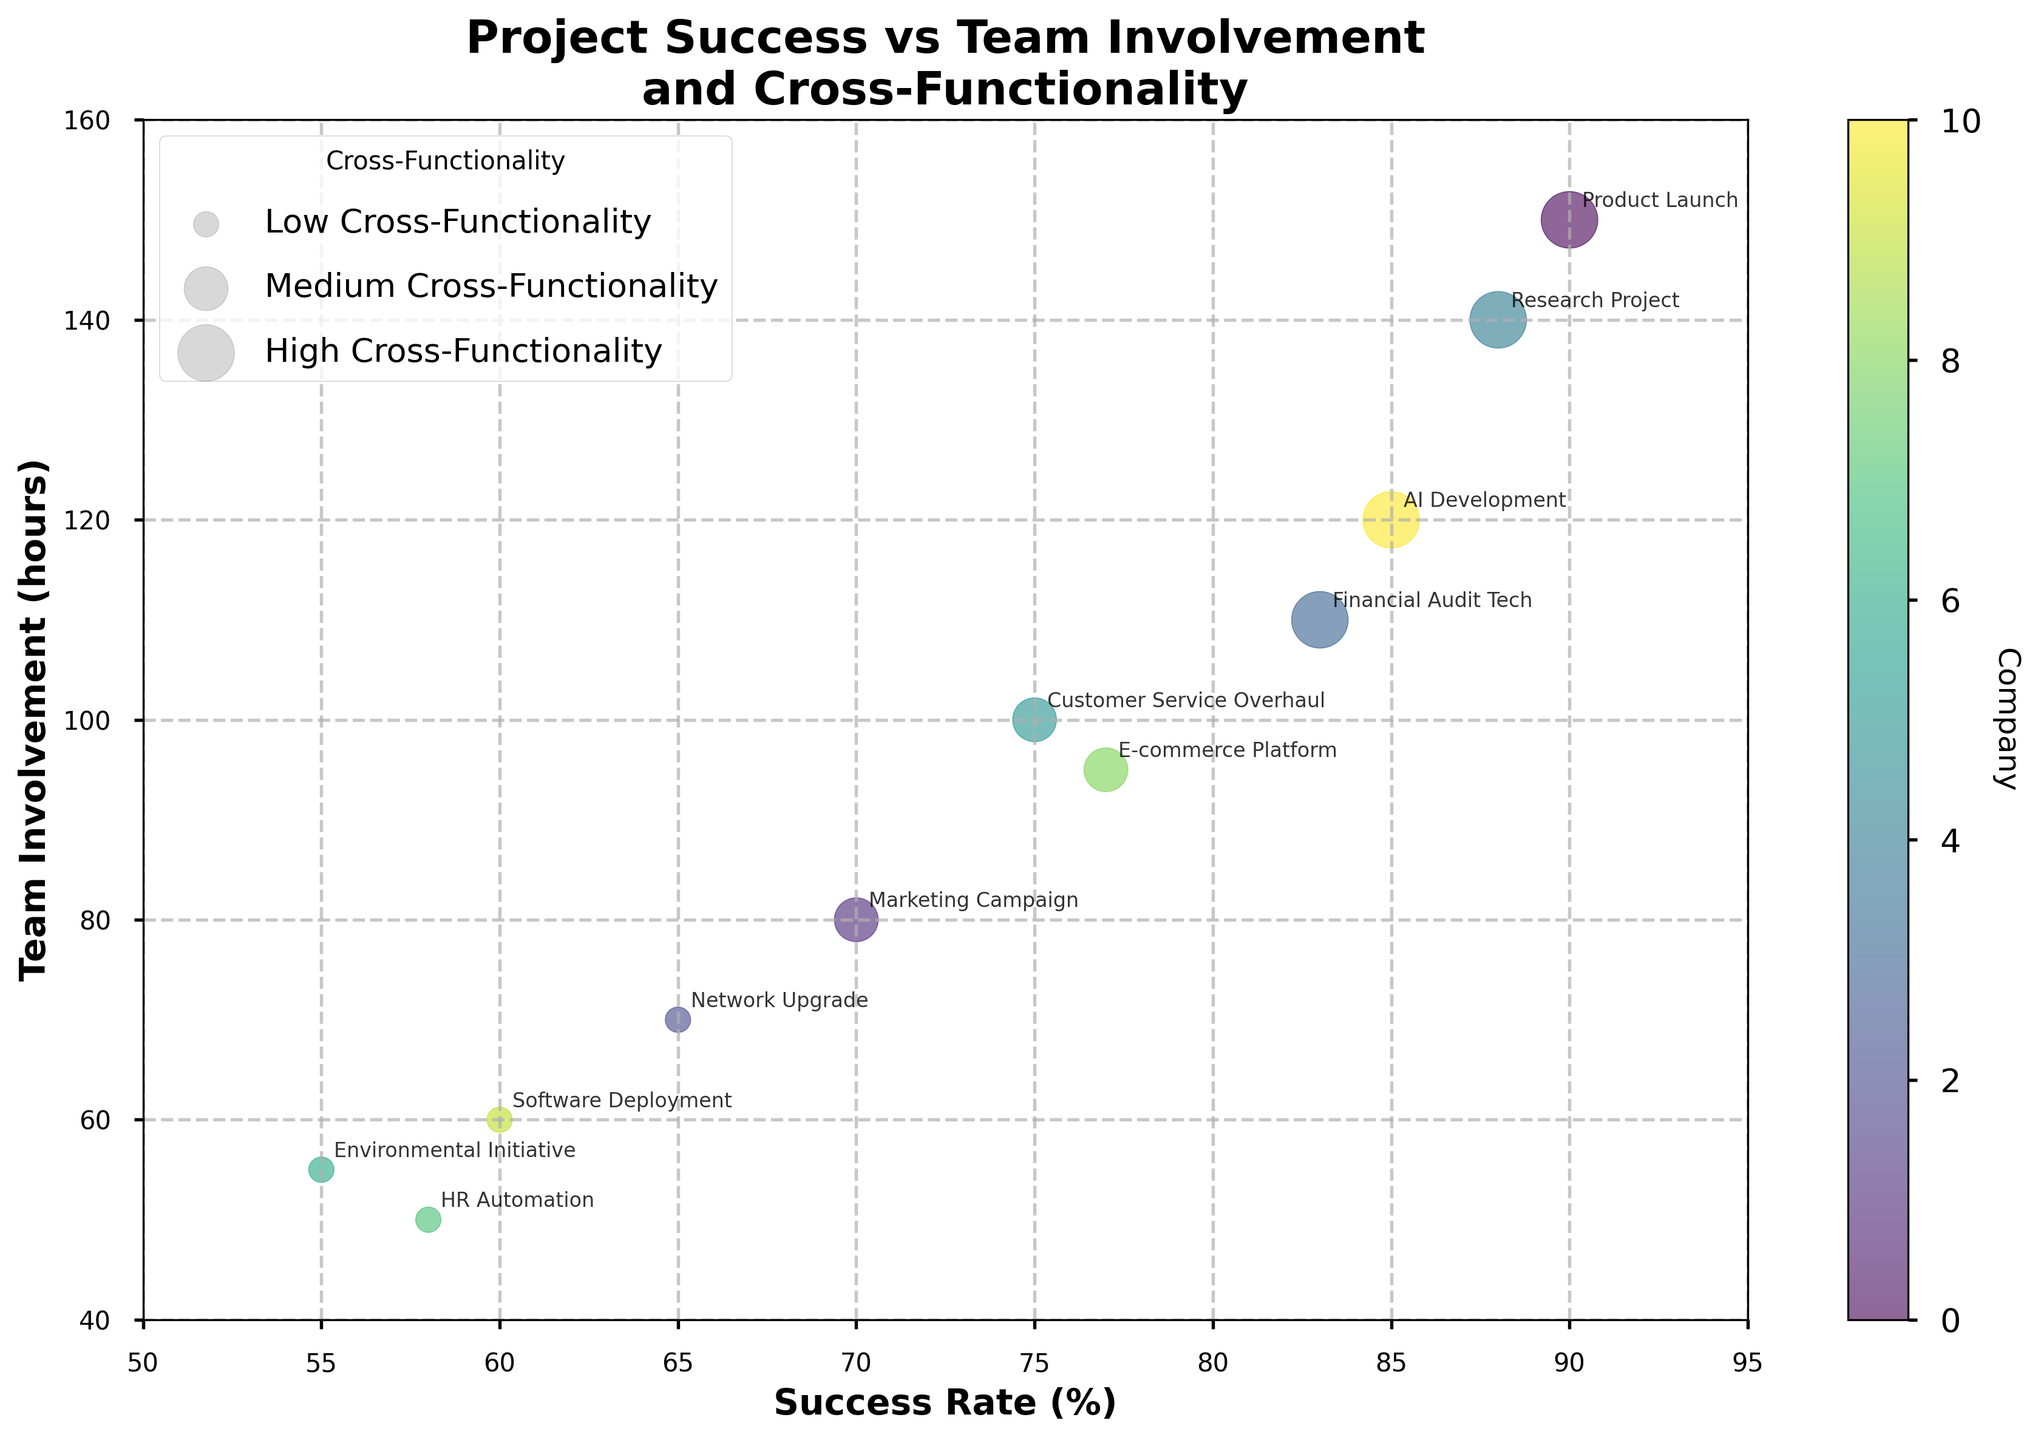How many projects have 'High' Cross-Functionality? Observe the legend, which explains that the largest bubbles represent 'High' Cross-Functionality. Count all the largest bubbles in the plot.
Answer: 4 What is the project with the highest success rate? Look for the data point with the highest value on the x-axis, representing the success rate. Then, refer to the label attached to that bubble.
Answer: Product Launch Compare the success rate of 'AI Development' and 'Financial Audit Tech'. Which is higher? Find the bubbles labeled 'AI Development' and 'Financial Audit Tech', and check their positions on the x-axis. 'AI Development' is at 85%, and 'Financial Audit Tech' is at 83%.
Answer: AI Development Which project has the lowest team involvement? Refer to the y-axis values. Identify the bubble with the lowest position on the y-axis. The label attached to this bubble indicates the project.
Answer: HR Automation Does 'Global Customer Care' have higher or lower success rate than 'Photonics Ltd'? Locate the bubbles for 'Global Customer Care' and 'Photonics Ltd' and compare their x-axis positions. 'Global Customer Care' is at 75%, and 'Photonics Ltd' is at 60%.
Answer: Higher What is the average success rate of projects with 'Medium' Cross-Functionality? Identify the medium-sized bubbles which represent 'Medium' Cross-Functionality. Read the success rates from the x-axis for those projects (70%, 75%, 77%). Calculate the average: (70 + 75 + 77) / 3 = 74.
Answer: 74 Which company has the highest cross-functionality involvement? Refer to the legend which explains the sizes of bubbles. The largest bubble, 'Product Launch', belongs to 'Aeronautics Corp', representing the highest 'Degree of Cross-Functionality'.
Answer: Aeronautics Corp Compare the team involvement of 'Marketing Campaign' and 'Network Upgrade'. Which project involved more team hours? Find the bubbles labeled 'Marketing Campaign' and 'Network Upgrade' and check their positions on the y-axis. 'Marketing Campaign' is at 80 hours, and 'Network Upgrade' is at 70 hours.
Answer: Marketing Campaign What is the relationship between 'Success Rate' and 'Team Involvement' shown in the plot? Observe the plot to see the overall trend of data points. Higher success rates tend to align with higher team involvement, indicating a positive correlation.
Answer: Positive correlation How many companies are represented in the plot? The color legend indicates different companies. Count the distinct colors or check for the color bar to identify the number of unique companies, which is 11.
Answer: 11 